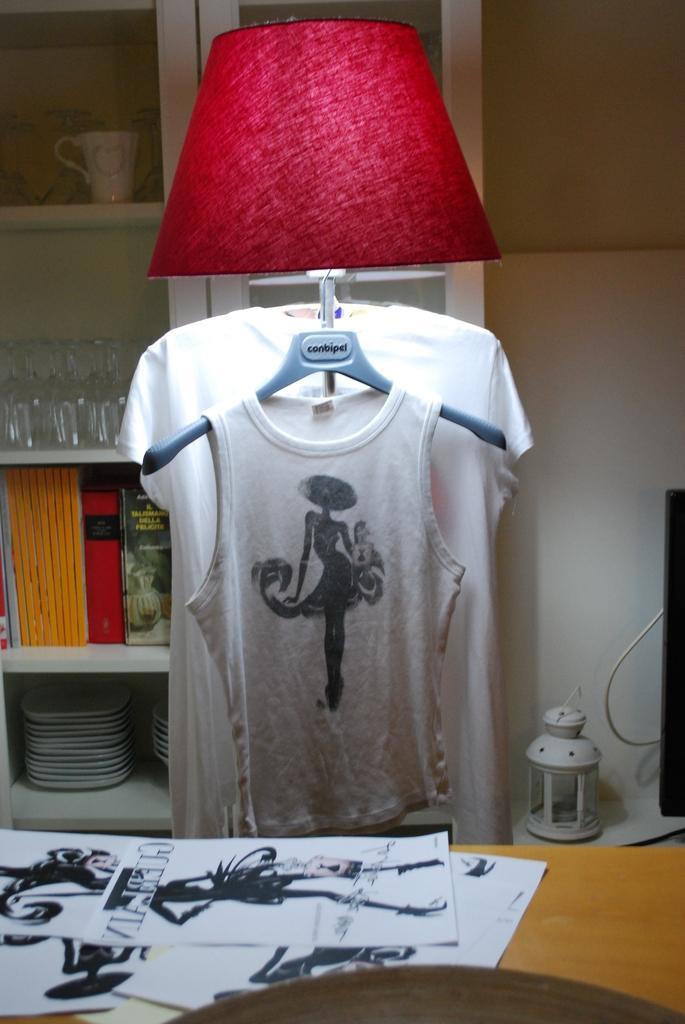Describe this image in one or two sentences. In this picture we can see the papers on the table and at the background, we can see a bed lamp, T-shirt and other things. 